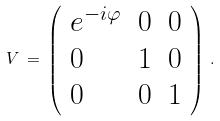Convert formula to latex. <formula><loc_0><loc_0><loc_500><loc_500>V \, = \, \left ( \begin{array} { l l l } { { e ^ { - i \varphi } } } & { 0 } & { 0 } \\ { 0 } & { 1 } & { 0 } \\ { 0 } & { 0 } & { 1 } \end{array} \right ) \, .</formula> 